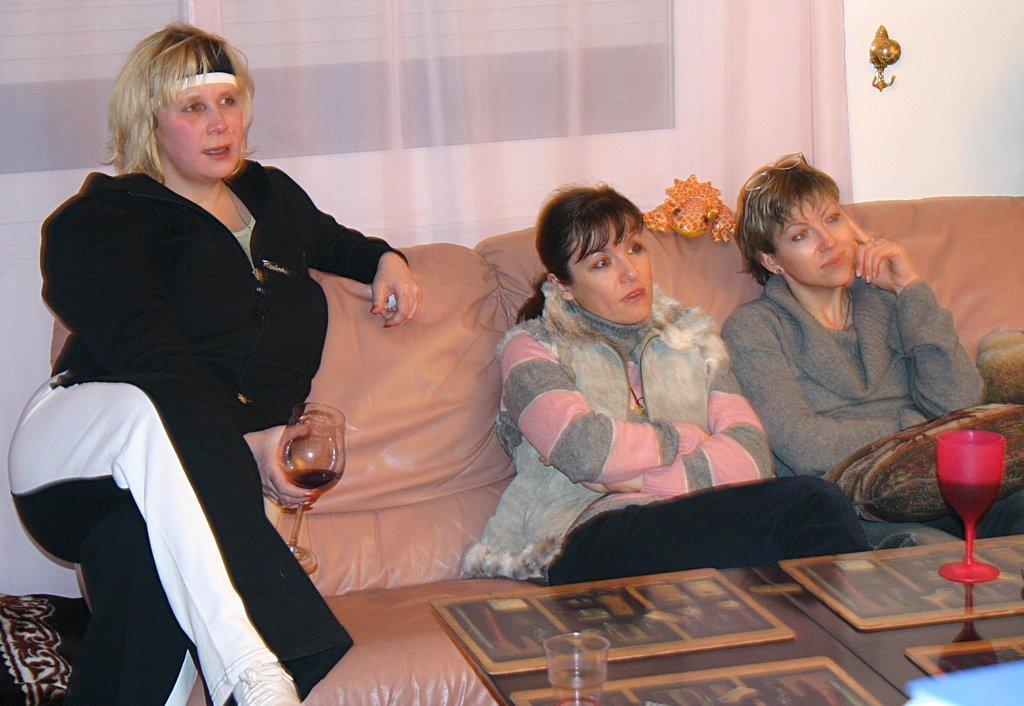Can you describe this image briefly? There are three women sitting on the couch. This is a table with a red wine glass placed on it. This looks like a toy on the couch. This is a white curtain cloth hanging. And some object is attached to the wall. 